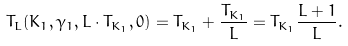Convert formula to latex. <formula><loc_0><loc_0><loc_500><loc_500>T _ { L } ( K _ { 1 } , \gamma _ { 1 } , L \cdot T _ { K _ { 1 } } , 0 ) = T _ { K _ { 1 } } + \frac { T _ { K _ { 1 } } } { L } = T _ { K _ { 1 } } \frac { L + 1 } { L } .</formula> 